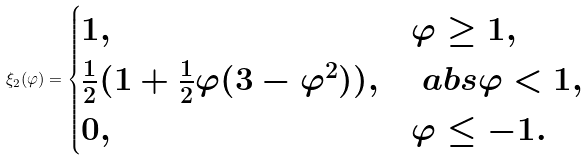Convert formula to latex. <formula><loc_0><loc_0><loc_500><loc_500>\xi _ { 2 } ( \varphi ) = \begin{cases} 1 , & \varphi \geq 1 , \\ \frac { 1 } { 2 } ( 1 + \frac { 1 } { 2 } \varphi ( 3 - \varphi ^ { 2 } ) ) , & \ a b s { \varphi } < 1 , \\ 0 , & \varphi \leq - 1 . \end{cases}</formula> 